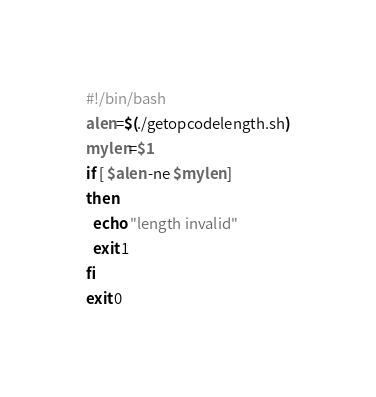<code> <loc_0><loc_0><loc_500><loc_500><_Bash_>#!/bin/bash
alen=$(./getopcodelength.sh)
mylen=$1
if [ $alen -ne $mylen ]
then
  echo "length invalid"
  exit 1
fi
exit 0
</code> 